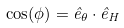Convert formula to latex. <formula><loc_0><loc_0><loc_500><loc_500>\cos ( \phi ) = \hat { e } _ { \theta } \cdot \hat { e } _ { H }</formula> 